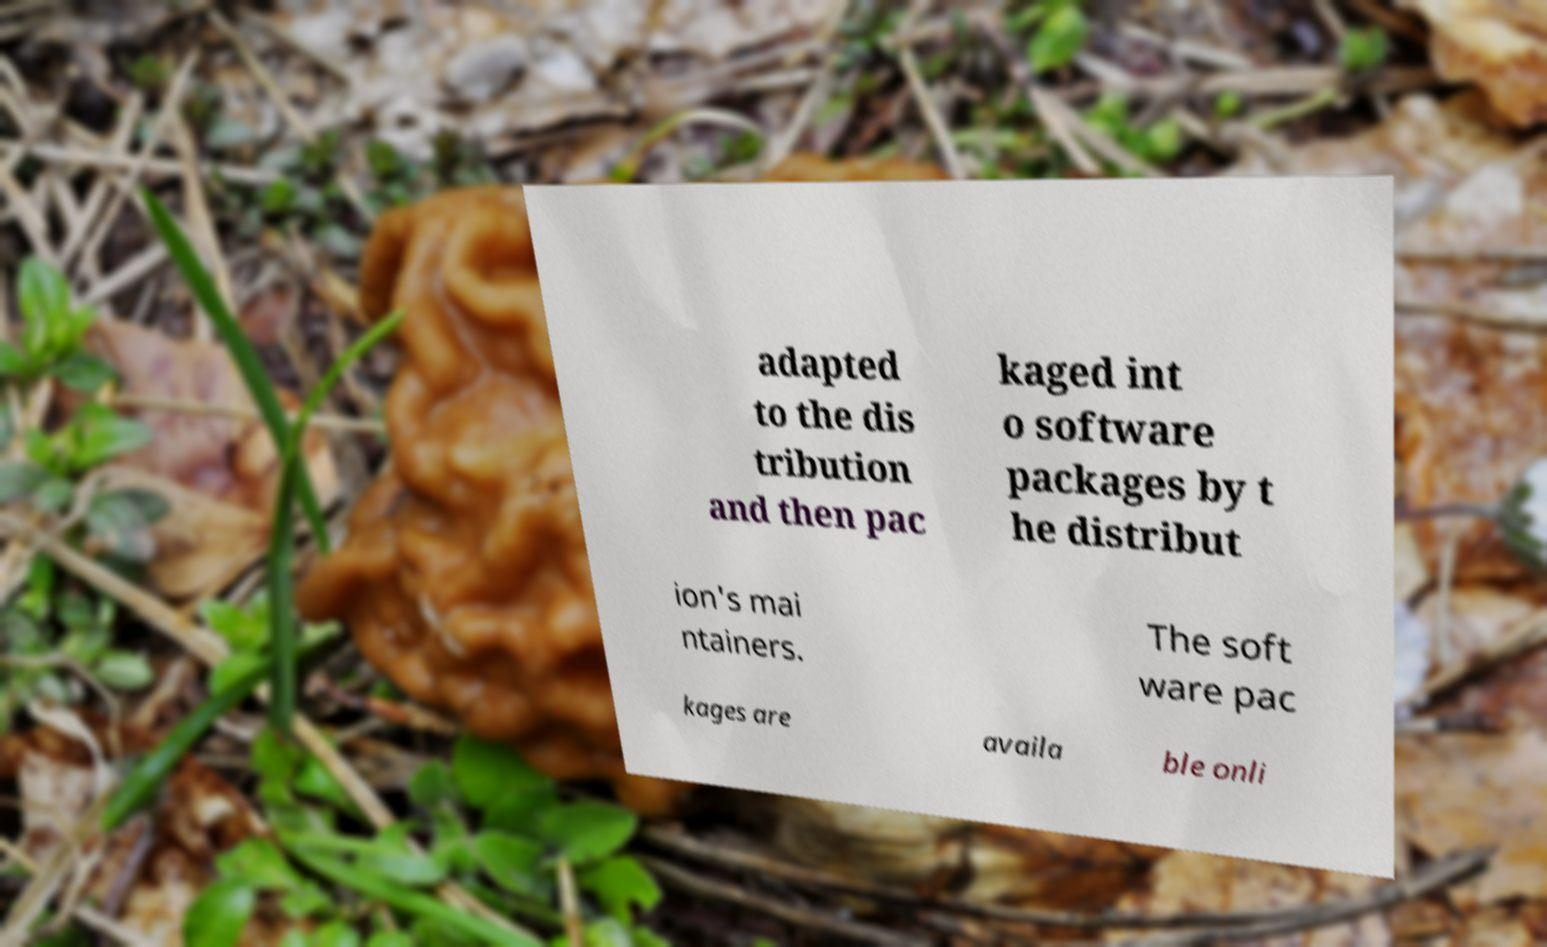For documentation purposes, I need the text within this image transcribed. Could you provide that? adapted to the dis tribution and then pac kaged int o software packages by t he distribut ion's mai ntainers. The soft ware pac kages are availa ble onli 